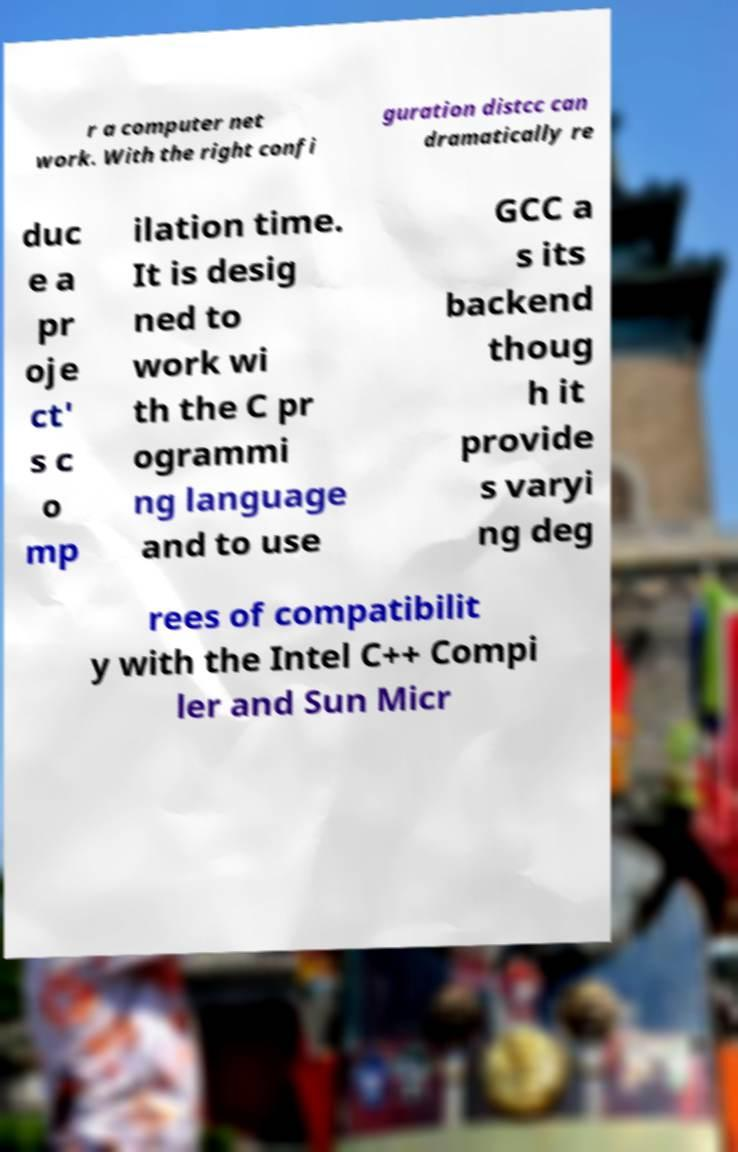I need the written content from this picture converted into text. Can you do that? r a computer net work. With the right confi guration distcc can dramatically re duc e a pr oje ct' s c o mp ilation time. It is desig ned to work wi th the C pr ogrammi ng language and to use GCC a s its backend thoug h it provide s varyi ng deg rees of compatibilit y with the Intel C++ Compi ler and Sun Micr 